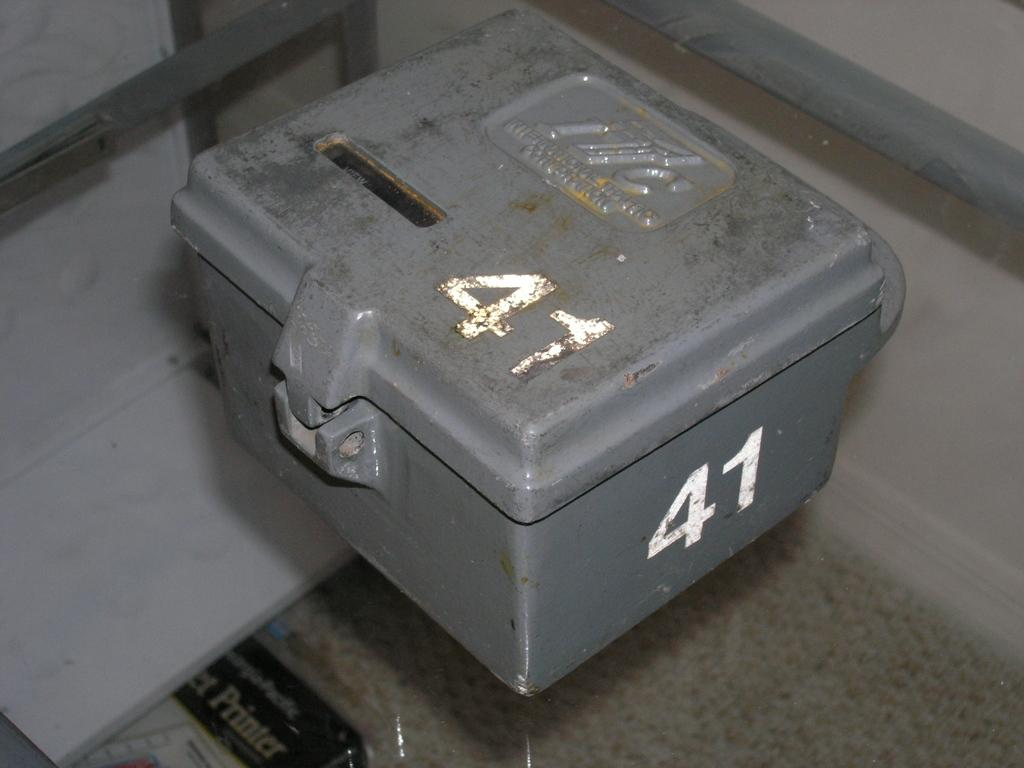<image>
Relay a brief, clear account of the picture shown. A heavy looking grey metal box with the white numbers 41 on it. 